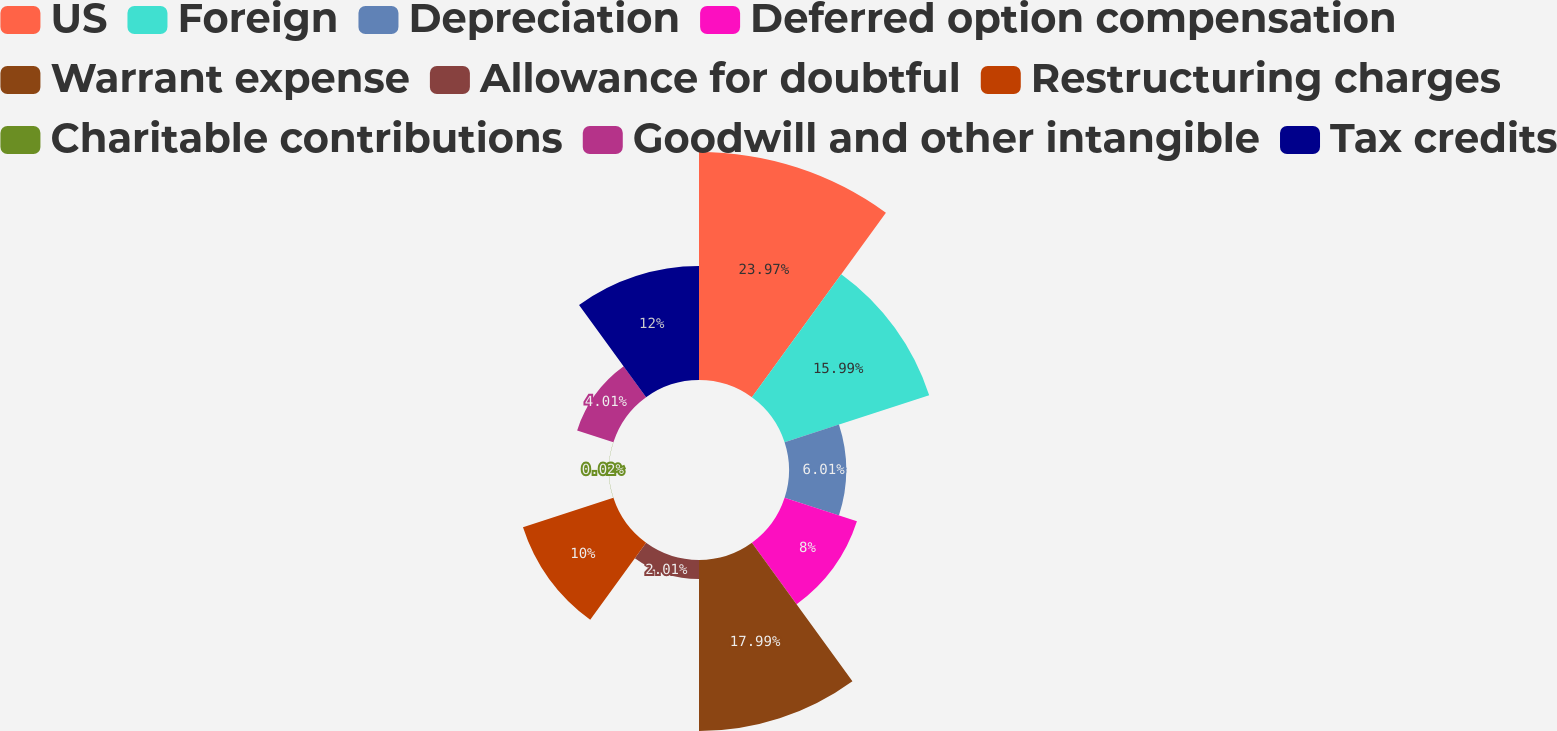Convert chart. <chart><loc_0><loc_0><loc_500><loc_500><pie_chart><fcel>US<fcel>Foreign<fcel>Depreciation<fcel>Deferred option compensation<fcel>Warrant expense<fcel>Allowance for doubtful<fcel>Restructuring charges<fcel>Charitable contributions<fcel>Goodwill and other intangible<fcel>Tax credits<nl><fcel>23.98%<fcel>15.99%<fcel>6.01%<fcel>8.0%<fcel>17.99%<fcel>2.01%<fcel>10.0%<fcel>0.02%<fcel>4.01%<fcel>12.0%<nl></chart> 